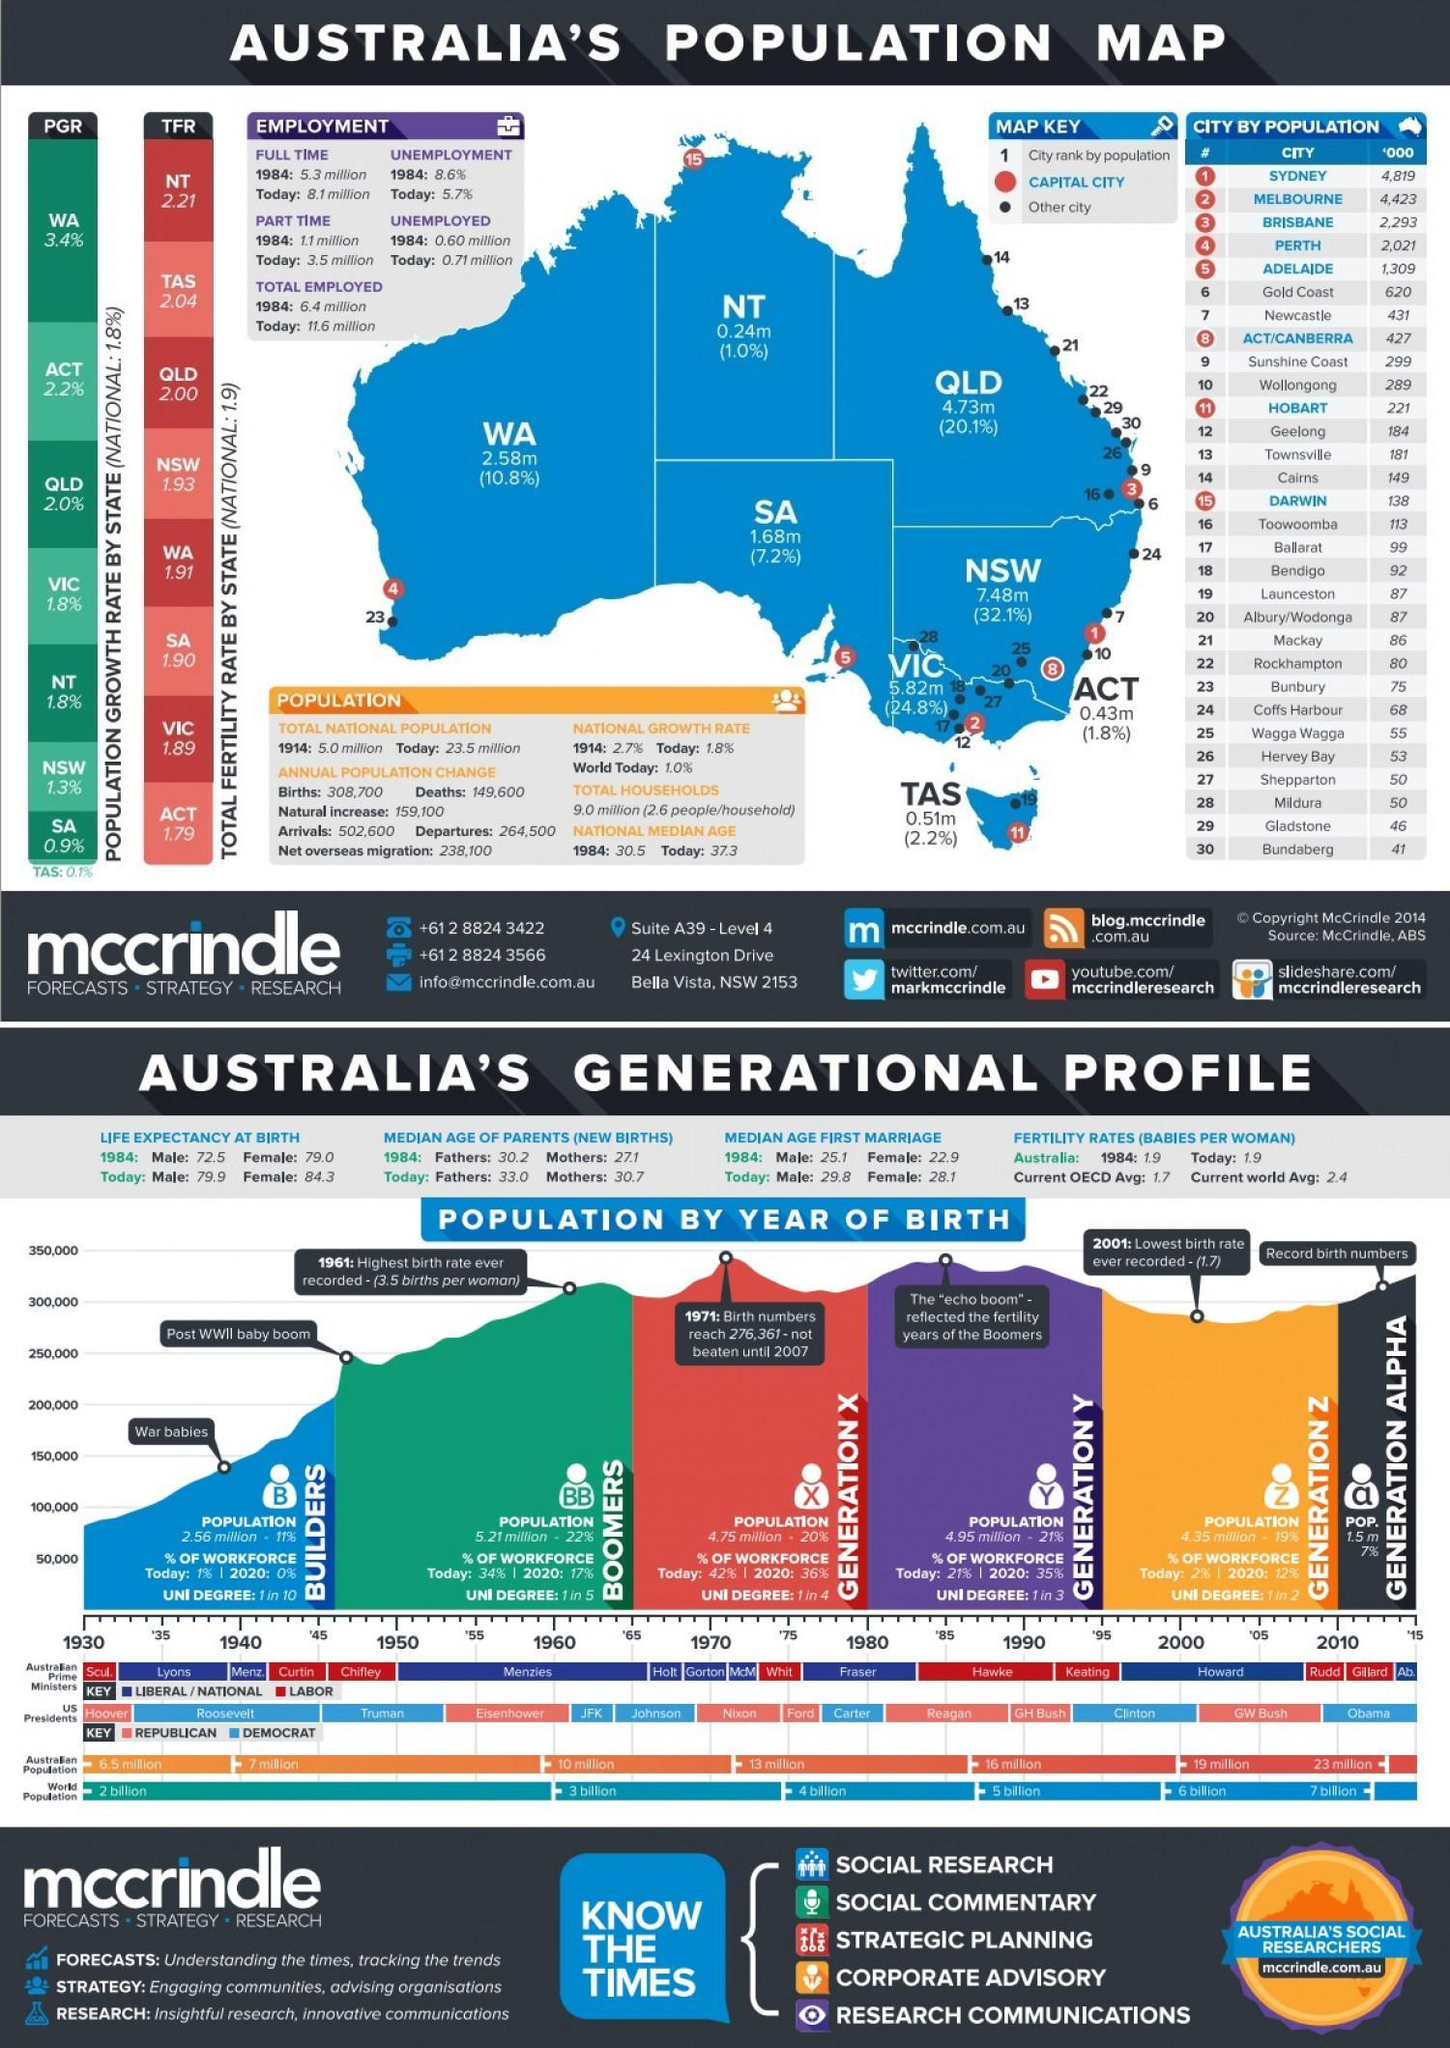Which is the most populated city in Australia?
Answer the question with a short phrase. SYDNEY Which is the capital city of Western Australia(WA)? PERTH What is the total fertility rate in Western Australia? 1.91 What is the national population growth rate of Australia in the year 1914? 2.7% What is the part time employed population of Australia in 1984? 1.1 million Which is the capital city of Tasmania(TAS)? HOBART What is the natural increase in the annual population in the year 1914? 159,100 What is the population growth rate in Victoria? 1.8% 